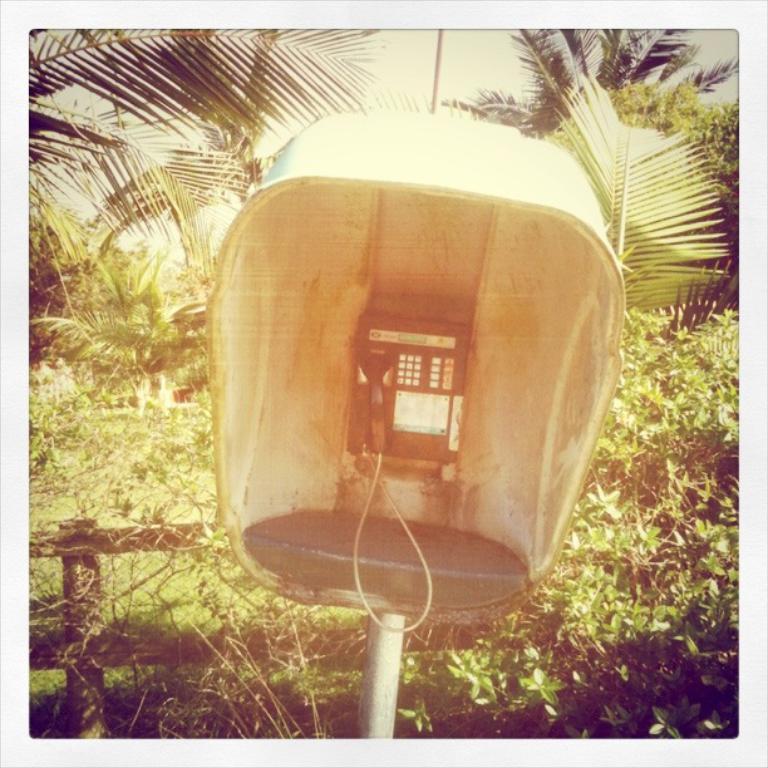Describe this image in one or two sentences. In the picture we can see a telephone on the stand which is on the pole and behind it, we can see a railing and plants behind it and trees and we can also see a part of the sky. 